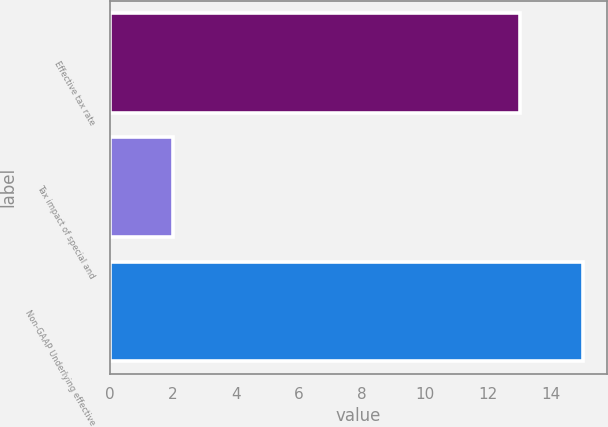Convert chart. <chart><loc_0><loc_0><loc_500><loc_500><bar_chart><fcel>Effective tax rate<fcel>Tax impact of special and<fcel>Non-GAAP Underlying effective<nl><fcel>13<fcel>2<fcel>15<nl></chart> 